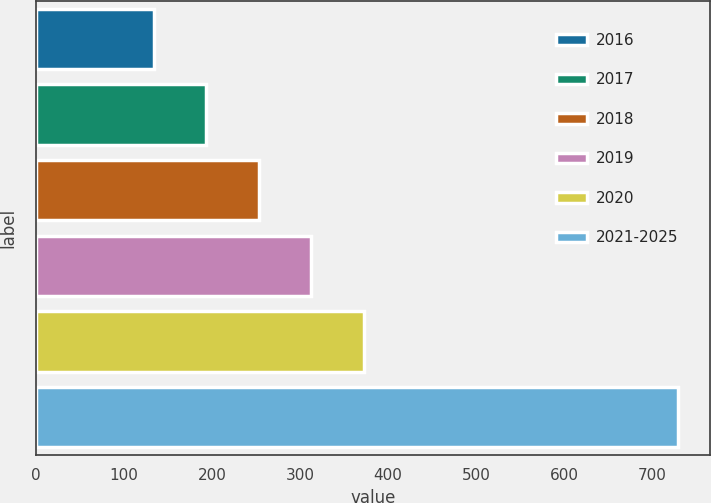Convert chart. <chart><loc_0><loc_0><loc_500><loc_500><bar_chart><fcel>2016<fcel>2017<fcel>2018<fcel>2019<fcel>2020<fcel>2021-2025<nl><fcel>134<fcel>193.6<fcel>253.2<fcel>312.8<fcel>372.4<fcel>730<nl></chart> 